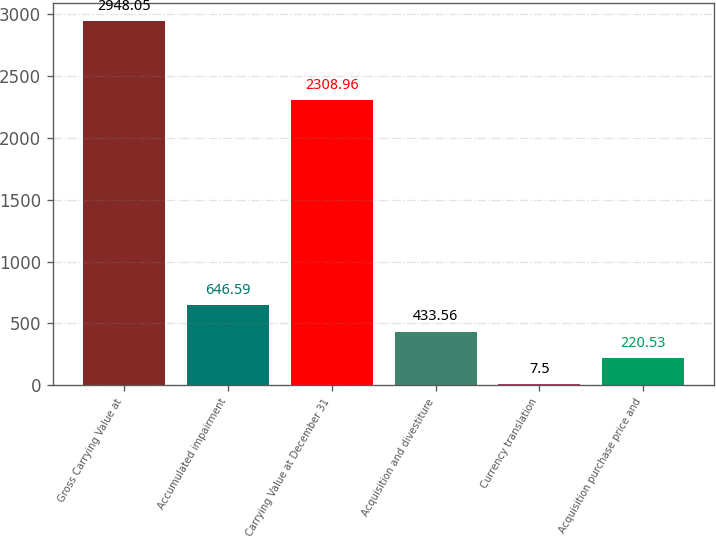<chart> <loc_0><loc_0><loc_500><loc_500><bar_chart><fcel>Gross Carrying Value at<fcel>Accumulated impairment<fcel>Carrying Value at December 31<fcel>Acquisition and divestiture<fcel>Currency translation<fcel>Acquisition purchase price and<nl><fcel>2948.05<fcel>646.59<fcel>2308.96<fcel>433.56<fcel>7.5<fcel>220.53<nl></chart> 